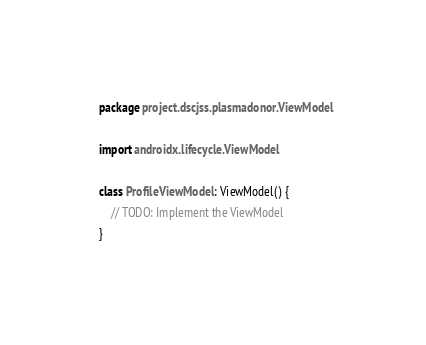<code> <loc_0><loc_0><loc_500><loc_500><_Kotlin_>package project.dscjss.plasmadonor.ViewModel

import androidx.lifecycle.ViewModel

class ProfileViewModel : ViewModel() {
    // TODO: Implement the ViewModel
}
</code> 